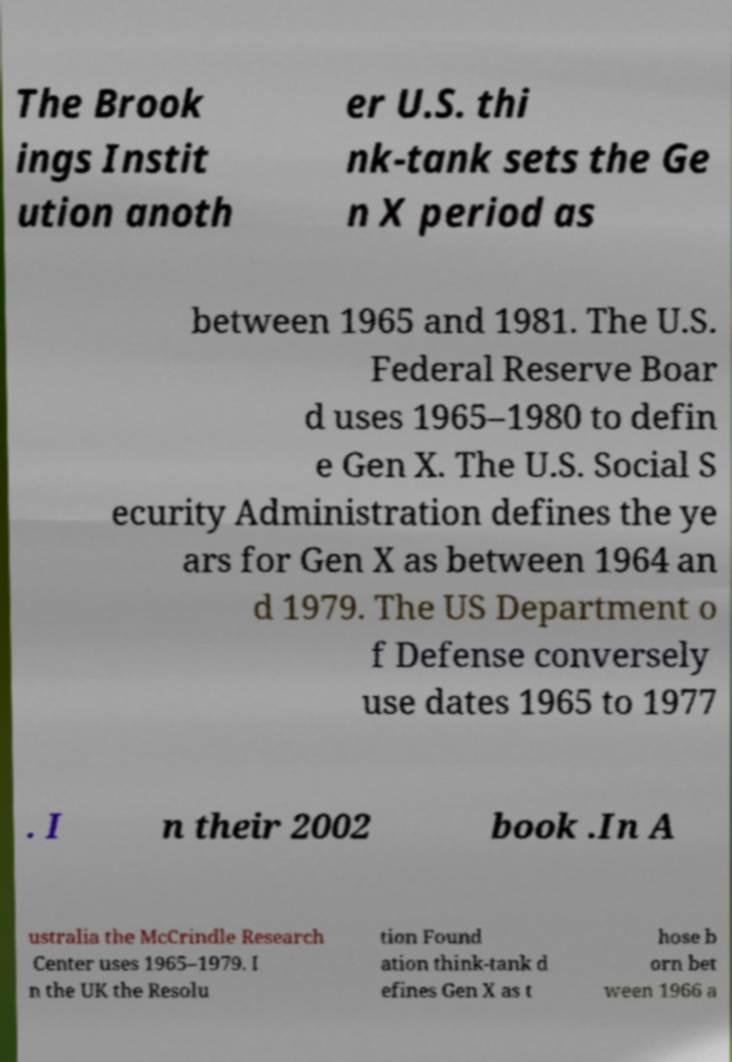Please read and relay the text visible in this image. What does it say? The Brook ings Instit ution anoth er U.S. thi nk-tank sets the Ge n X period as between 1965 and 1981. The U.S. Federal Reserve Boar d uses 1965–1980 to defin e Gen X. The U.S. Social S ecurity Administration defines the ye ars for Gen X as between 1964 an d 1979. The US Department o f Defense conversely use dates 1965 to 1977 . I n their 2002 book .In A ustralia the McCrindle Research Center uses 1965–1979. I n the UK the Resolu tion Found ation think-tank d efines Gen X as t hose b orn bet ween 1966 a 